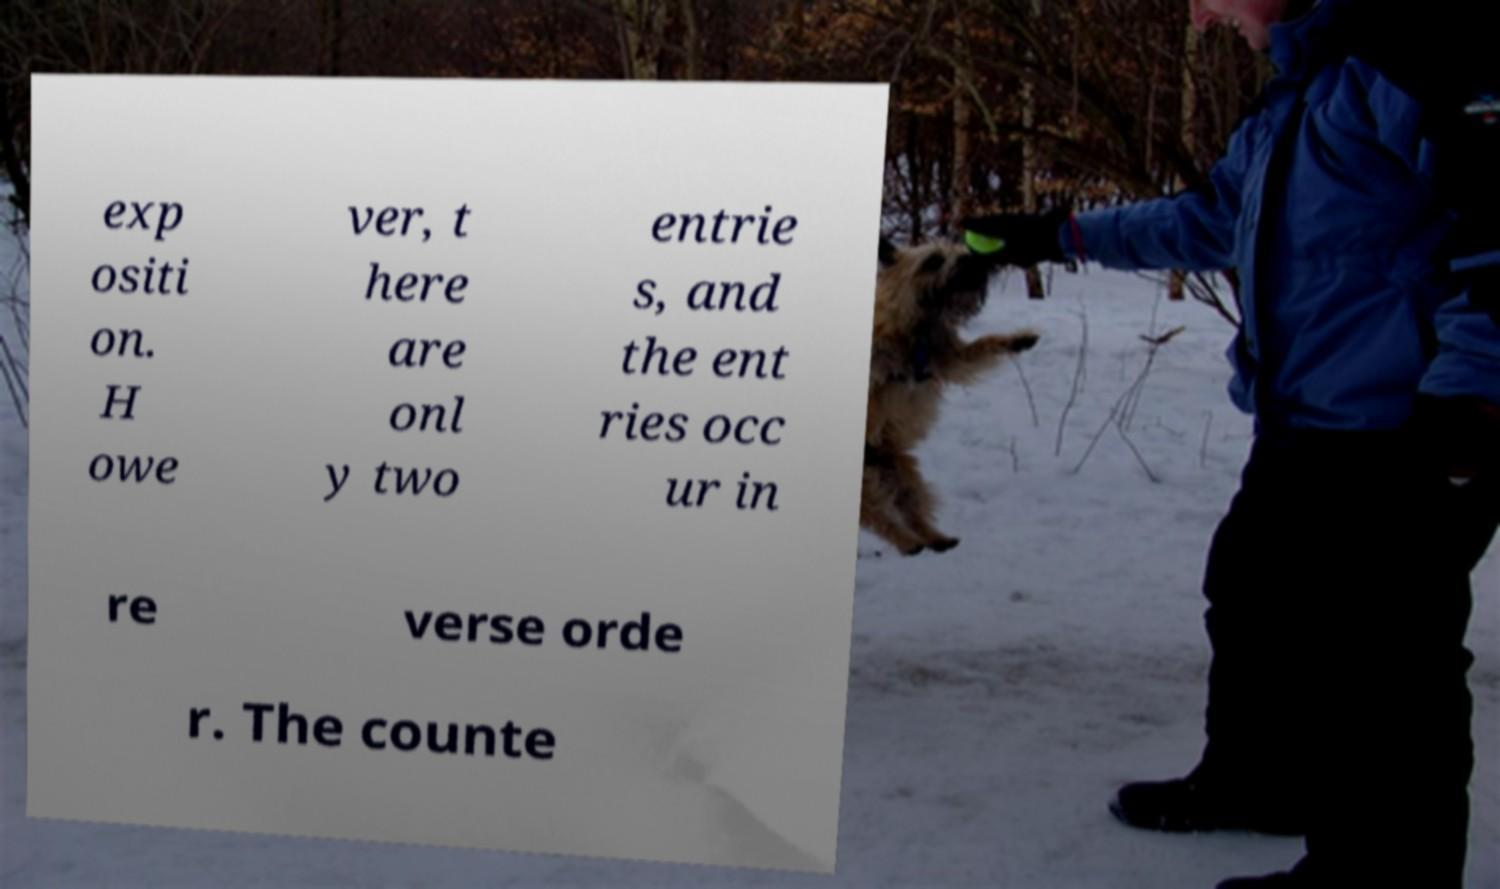Can you read and provide the text displayed in the image?This photo seems to have some interesting text. Can you extract and type it out for me? exp ositi on. H owe ver, t here are onl y two entrie s, and the ent ries occ ur in re verse orde r. The counte 